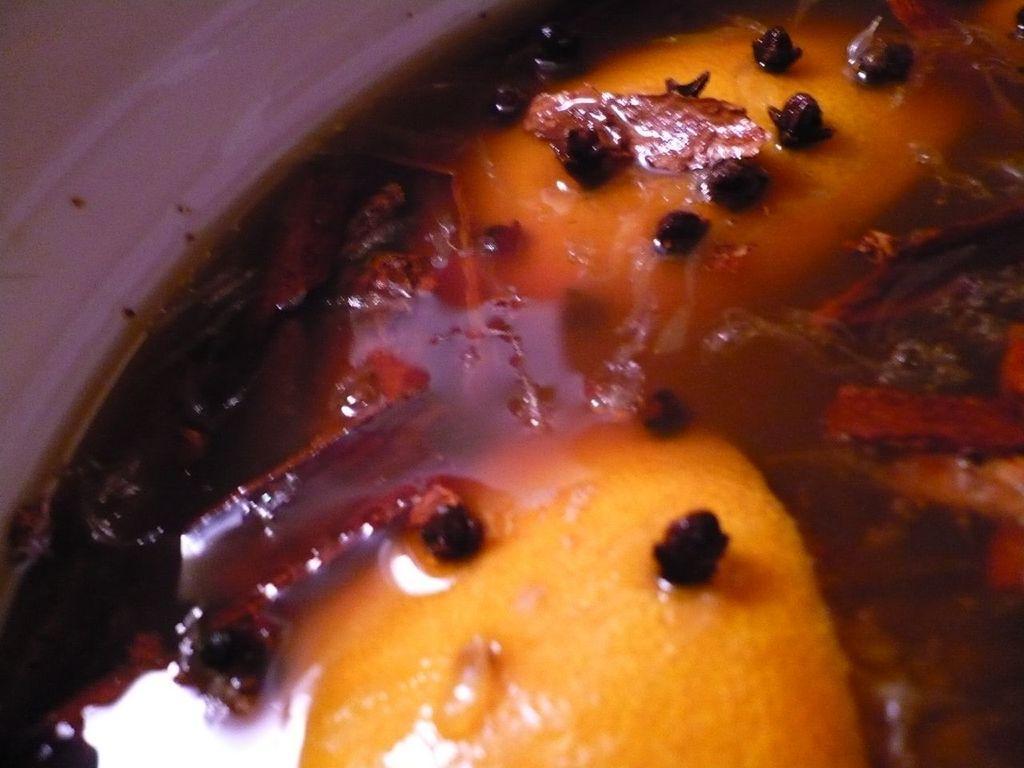In one or two sentences, can you explain what this image depicts? It seems like a food item. 